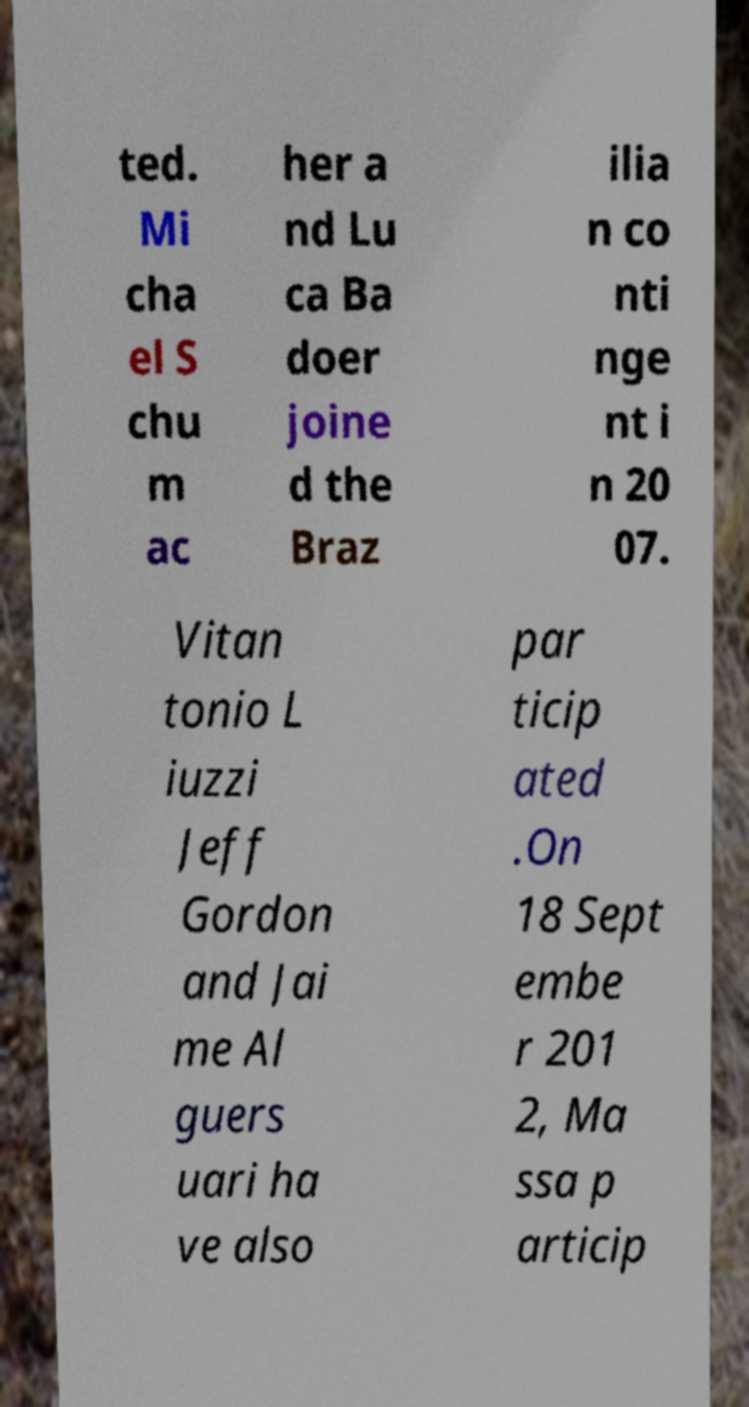Could you extract and type out the text from this image? ted. Mi cha el S chu m ac her a nd Lu ca Ba doer joine d the Braz ilia n co nti nge nt i n 20 07. Vitan tonio L iuzzi Jeff Gordon and Jai me Al guers uari ha ve also par ticip ated .On 18 Sept embe r 201 2, Ma ssa p articip 